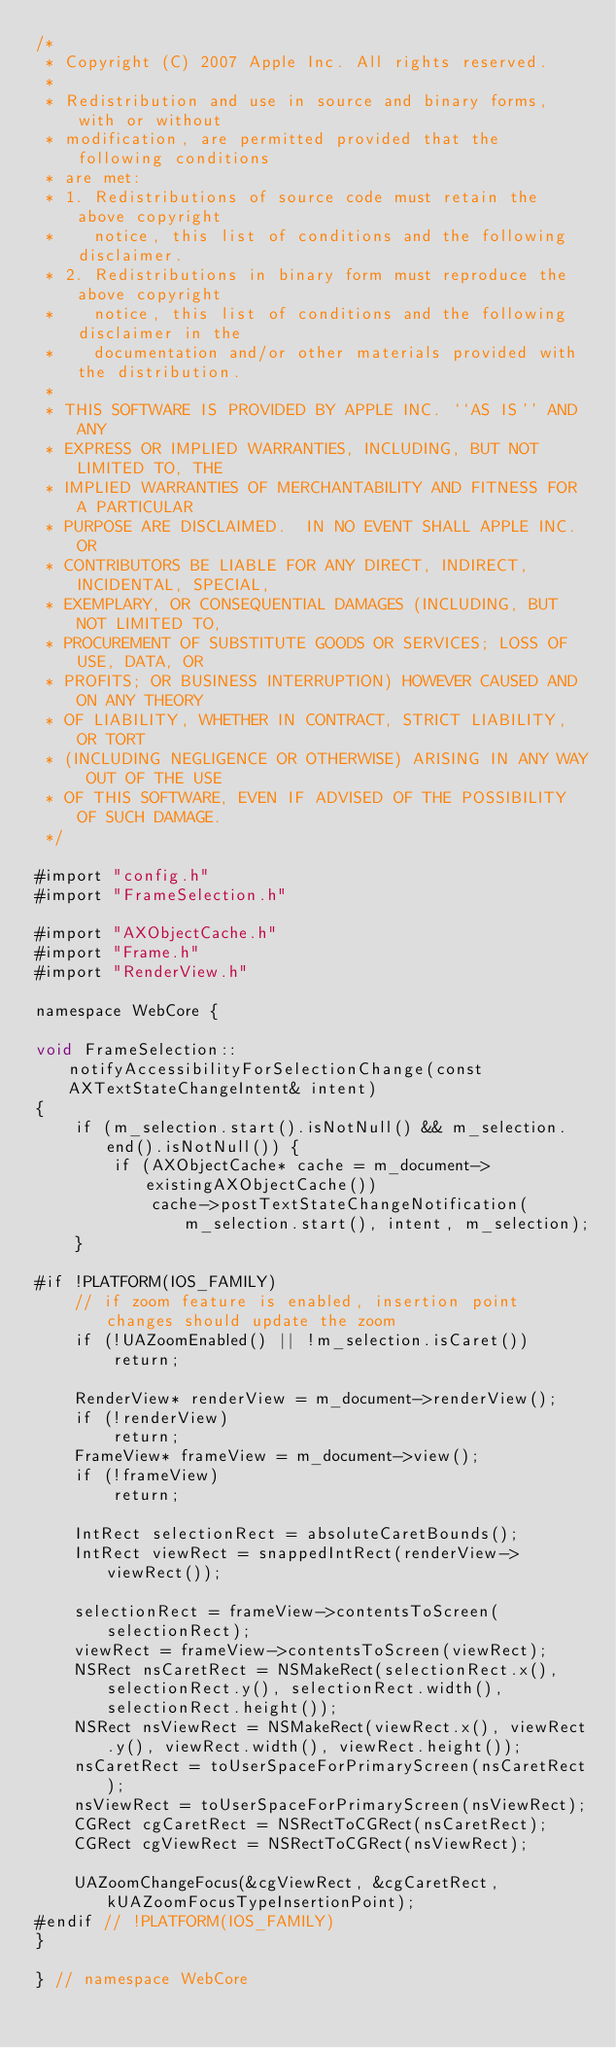<code> <loc_0><loc_0><loc_500><loc_500><_ObjectiveC_>/*
 * Copyright (C) 2007 Apple Inc. All rights reserved.
 *
 * Redistribution and use in source and binary forms, with or without
 * modification, are permitted provided that the following conditions
 * are met:
 * 1. Redistributions of source code must retain the above copyright
 *    notice, this list of conditions and the following disclaimer.
 * 2. Redistributions in binary form must reproduce the above copyright
 *    notice, this list of conditions and the following disclaimer in the
 *    documentation and/or other materials provided with the distribution.
 *
 * THIS SOFTWARE IS PROVIDED BY APPLE INC. ``AS IS'' AND ANY
 * EXPRESS OR IMPLIED WARRANTIES, INCLUDING, BUT NOT LIMITED TO, THE
 * IMPLIED WARRANTIES OF MERCHANTABILITY AND FITNESS FOR A PARTICULAR
 * PURPOSE ARE DISCLAIMED.  IN NO EVENT SHALL APPLE INC. OR
 * CONTRIBUTORS BE LIABLE FOR ANY DIRECT, INDIRECT, INCIDENTAL, SPECIAL,
 * EXEMPLARY, OR CONSEQUENTIAL DAMAGES (INCLUDING, BUT NOT LIMITED TO,
 * PROCUREMENT OF SUBSTITUTE GOODS OR SERVICES; LOSS OF USE, DATA, OR
 * PROFITS; OR BUSINESS INTERRUPTION) HOWEVER CAUSED AND ON ANY THEORY
 * OF LIABILITY, WHETHER IN CONTRACT, STRICT LIABILITY, OR TORT
 * (INCLUDING NEGLIGENCE OR OTHERWISE) ARISING IN ANY WAY OUT OF THE USE
 * OF THIS SOFTWARE, EVEN IF ADVISED OF THE POSSIBILITY OF SUCH DAMAGE. 
 */
 
#import "config.h"
#import "FrameSelection.h"

#import "AXObjectCache.h"
#import "Frame.h"
#import "RenderView.h"

namespace WebCore {

void FrameSelection::notifyAccessibilityForSelectionChange(const AXTextStateChangeIntent& intent)
{
    if (m_selection.start().isNotNull() && m_selection.end().isNotNull()) {
        if (AXObjectCache* cache = m_document->existingAXObjectCache())
            cache->postTextStateChangeNotification(m_selection.start(), intent, m_selection);
    }

#if !PLATFORM(IOS_FAMILY)
    // if zoom feature is enabled, insertion point changes should update the zoom
    if (!UAZoomEnabled() || !m_selection.isCaret())
        return;

    RenderView* renderView = m_document->renderView();
    if (!renderView)
        return;
    FrameView* frameView = m_document->view();
    if (!frameView)
        return;

    IntRect selectionRect = absoluteCaretBounds();
    IntRect viewRect = snappedIntRect(renderView->viewRect());

    selectionRect = frameView->contentsToScreen(selectionRect);
    viewRect = frameView->contentsToScreen(viewRect);
    NSRect nsCaretRect = NSMakeRect(selectionRect.x(), selectionRect.y(), selectionRect.width(), selectionRect.height());
    NSRect nsViewRect = NSMakeRect(viewRect.x(), viewRect.y(), viewRect.width(), viewRect.height());
    nsCaretRect = toUserSpaceForPrimaryScreen(nsCaretRect);
    nsViewRect = toUserSpaceForPrimaryScreen(nsViewRect);
    CGRect cgCaretRect = NSRectToCGRect(nsCaretRect);
    CGRect cgViewRect = NSRectToCGRect(nsViewRect);

    UAZoomChangeFocus(&cgViewRect, &cgCaretRect, kUAZoomFocusTypeInsertionPoint);
#endif // !PLATFORM(IOS_FAMILY)
}

} // namespace WebCore
</code> 